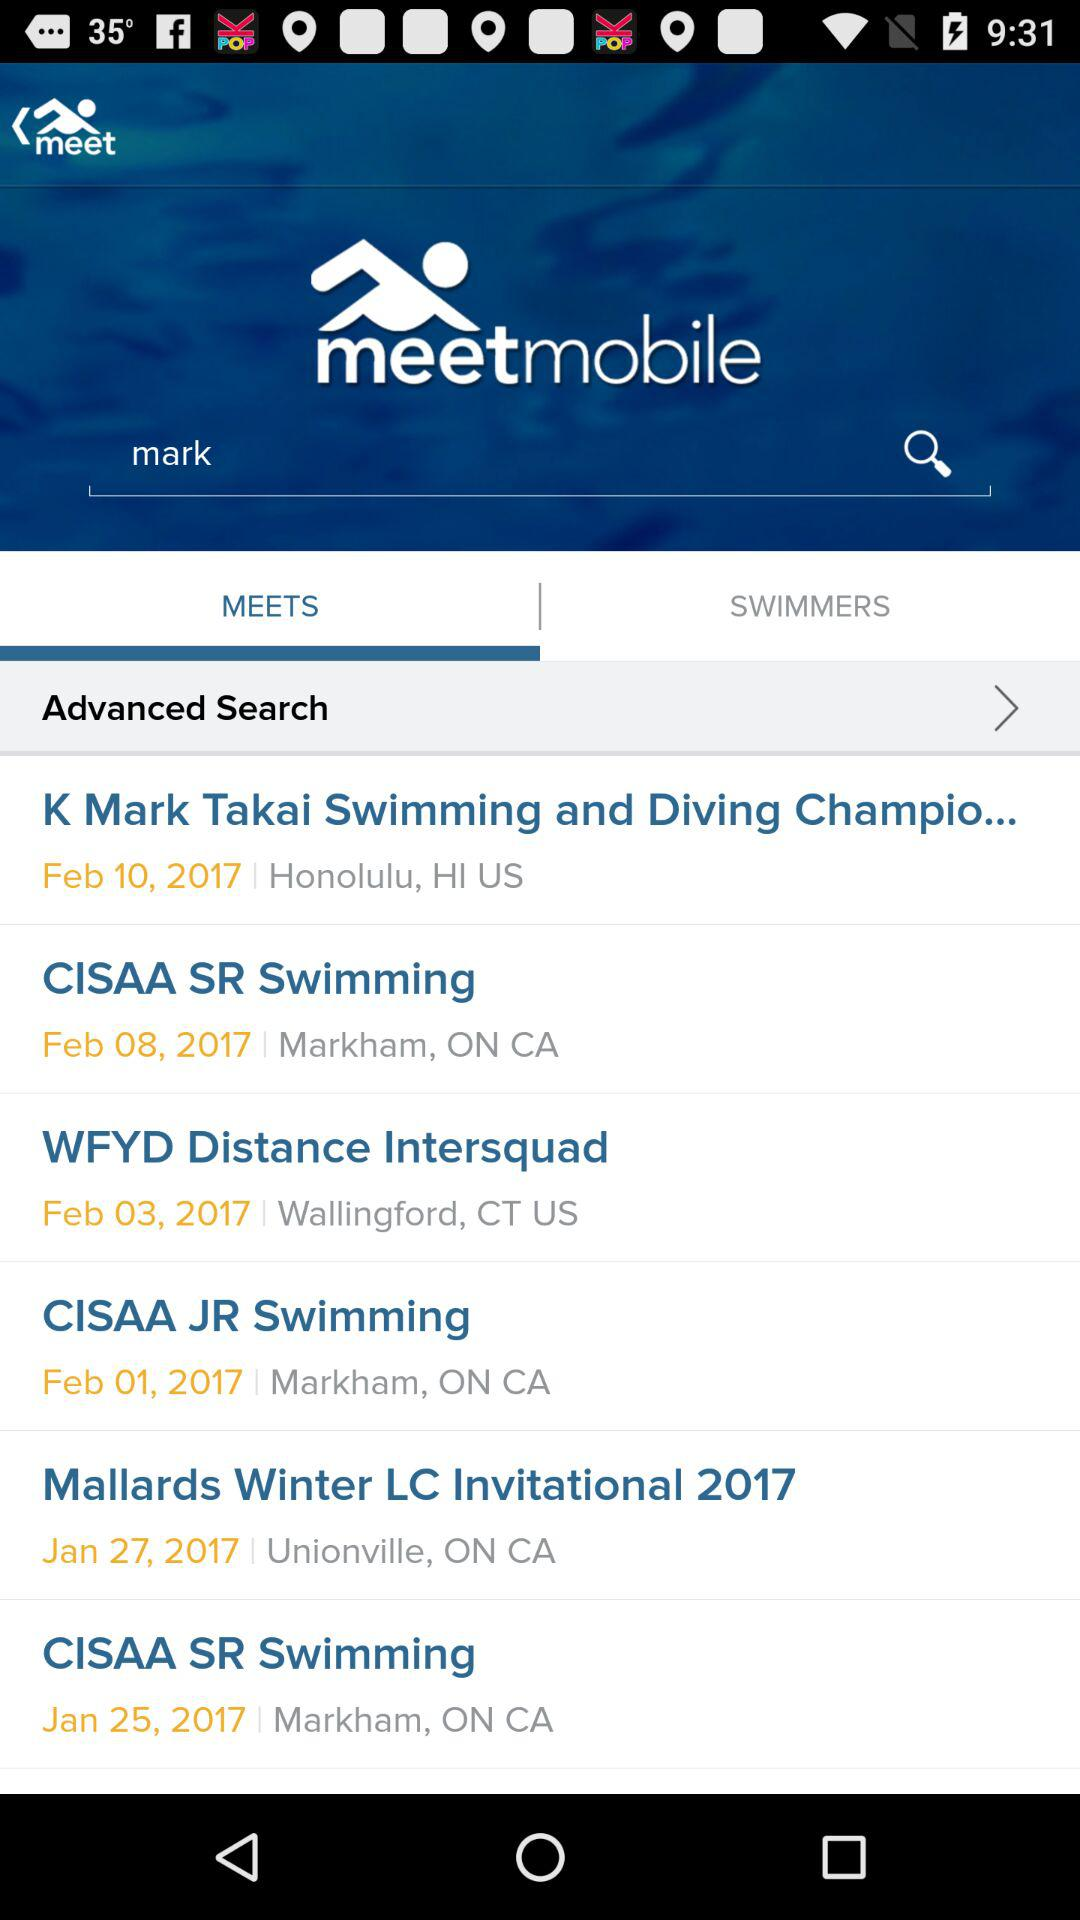What is the date of "CISAA JR Swimming? The date is February 1, 2017. 